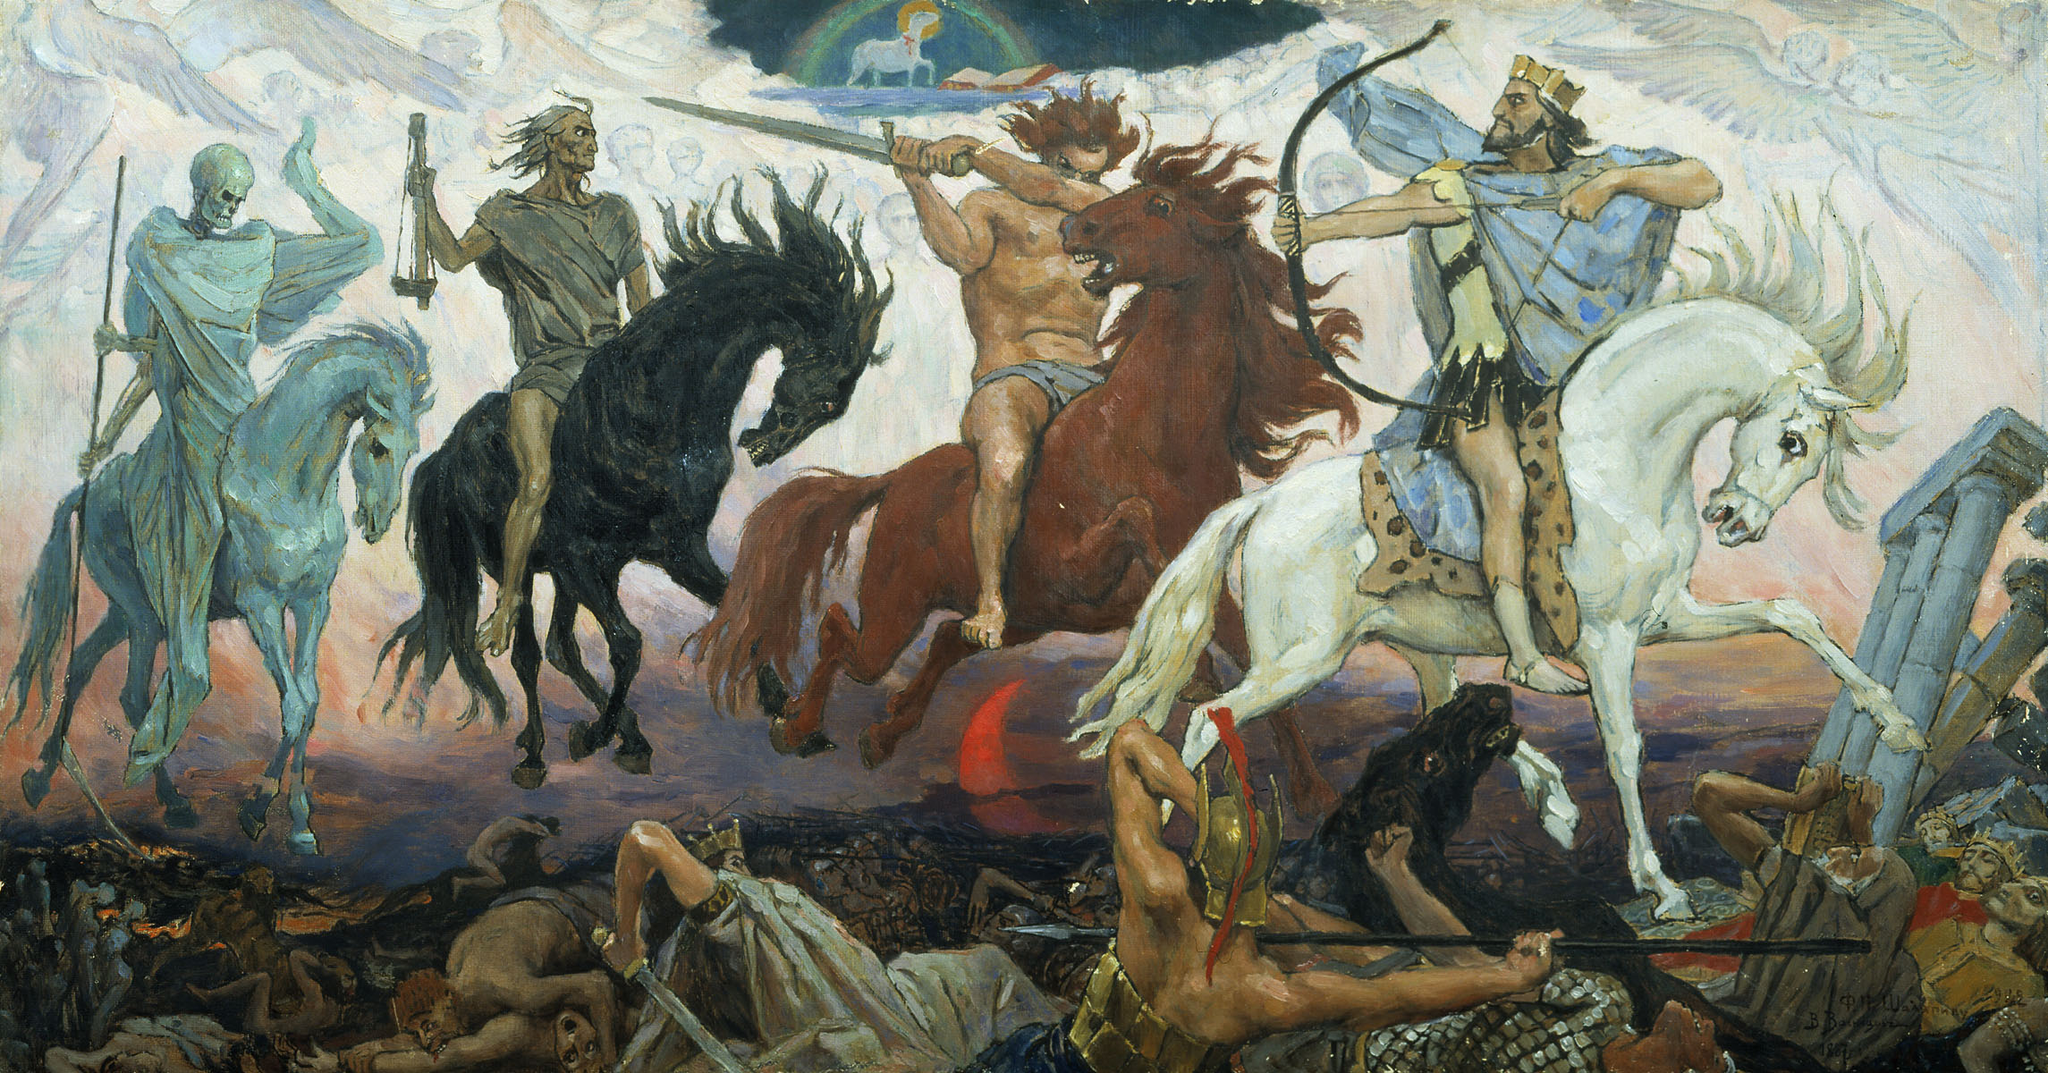Write a detailed description of the given image. The image depicts an intense and tumultuous battle scene filled with dynamic figures on horseback, distinctly illustrated in a style suggestive of the Baroque period, notable for its vivid emotional drama and intricate details. The painting uses a dramatic interplay of light and shadow, enhancing the movement within the scene and highlighting the expressions of agony and fury. The color scheme of predominantly earthy tones with bursts of red and blue adds to the painting's emotive quality. This piece could represent a mythical or historical battle, illustrating themes of heroism, chaos, and the human condition. The inclusion of symbolic elements like the skeletal figure on a pale horse could be interpreted as a representation of death or war itself, suggesting a deeper narrative at play. 